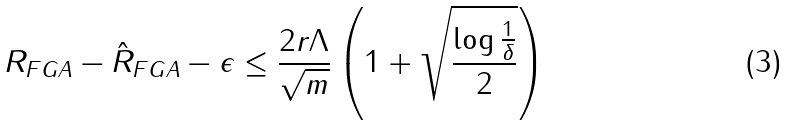Convert formula to latex. <formula><loc_0><loc_0><loc_500><loc_500>R _ { F G A } - \hat { R } _ { F G A } - \epsilon \leq \frac { 2 r \Lambda } { \sqrt { m } } \left ( 1 + \sqrt { \frac { \log \frac { 1 } { \delta } } { 2 } } \right )</formula> 